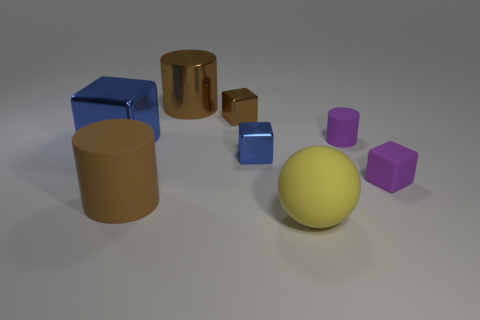Is the color of the big rubber cylinder the same as the large metal cylinder?
Make the answer very short. Yes. Is the tiny brown object made of the same material as the purple cylinder that is on the left side of the small purple cube?
Make the answer very short. No. What number of tiny cylinders are the same material as the big cube?
Make the answer very short. 0. There is a large shiny object to the right of the big shiny cube; what is its shape?
Ensure brevity in your answer.  Cylinder. Is the big cylinder that is behind the rubber cube made of the same material as the cylinder on the right side of the yellow object?
Your response must be concise. No. Are there any other objects that have the same shape as the brown matte object?
Your answer should be very brief. Yes. What number of things are either tiny things to the right of the ball or large cylinders?
Provide a succinct answer. 4. Is the number of purple cylinders that are behind the brown rubber cylinder greater than the number of metallic cylinders that are to the left of the yellow sphere?
Your answer should be compact. No. What number of shiny objects are either tiny purple cubes or blocks?
Provide a succinct answer. 3. There is a small thing that is the same color as the metal cylinder; what is it made of?
Your answer should be very brief. Metal. 